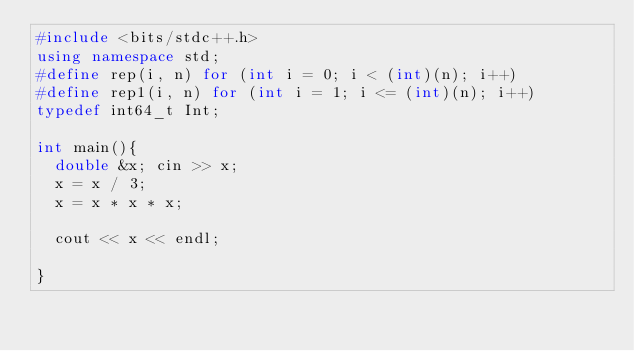Convert code to text. <code><loc_0><loc_0><loc_500><loc_500><_C++_>#include <bits/stdc++.h>
using namespace std;
#define rep(i, n) for (int i = 0; i < (int)(n); i++)
#define rep1(i, n) for (int i = 1; i <= (int)(n); i++)
typedef int64_t Int;

int main(){ 
  double &x; cin >> x;
  x = x / 3;
  x = x * x * x;
  
  cout << x << endl;

}</code> 